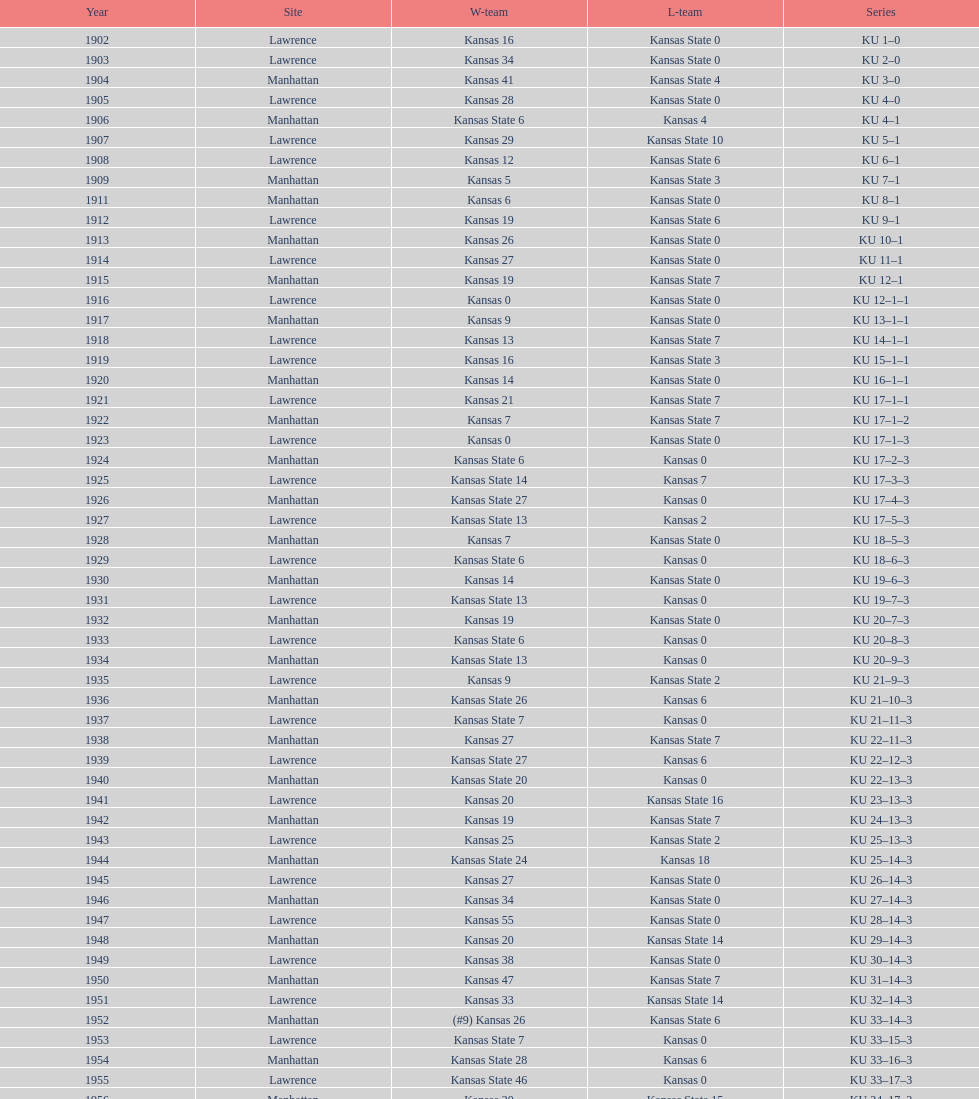When was the last time kansas state lost with 0 points in manhattan? 1964. 